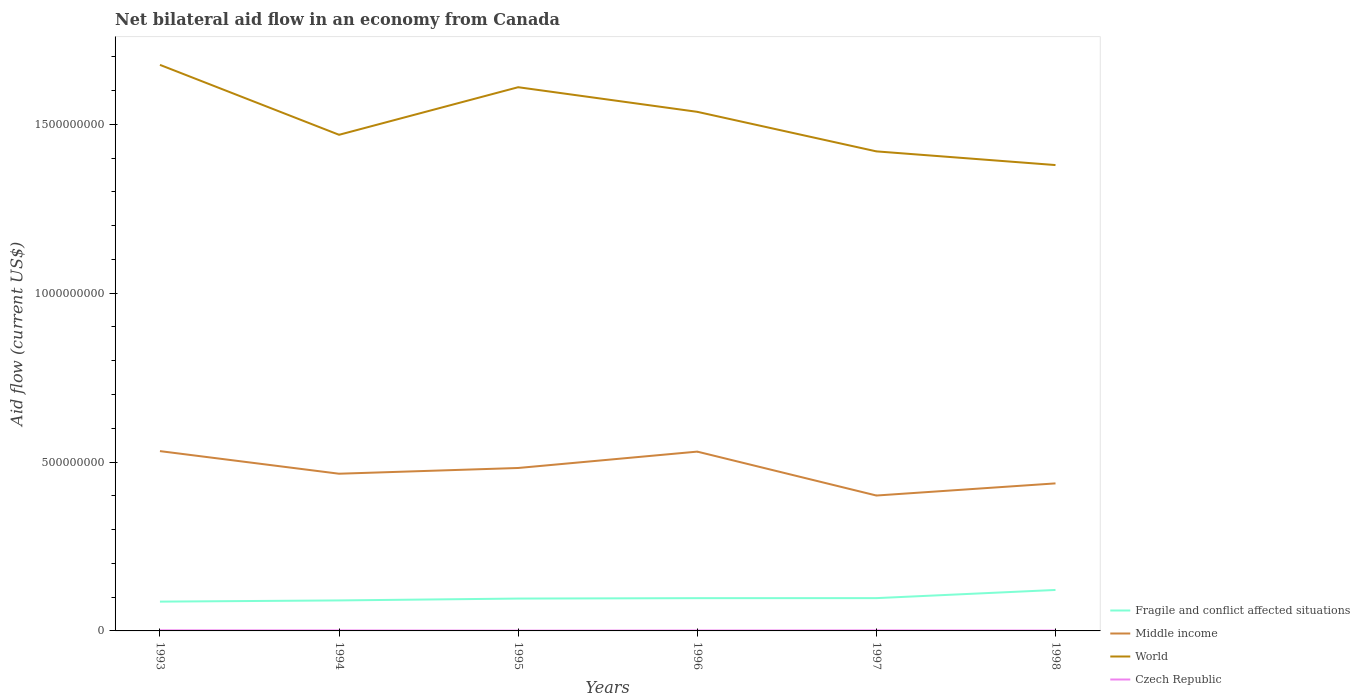How many different coloured lines are there?
Ensure brevity in your answer.  4. In which year was the net bilateral aid flow in Czech Republic maximum?
Your answer should be very brief. 1995. What is the total net bilateral aid flow in World in the graph?
Your response must be concise. 1.58e+08. What is the difference between the highest and the second highest net bilateral aid flow in Middle income?
Provide a short and direct response. 1.31e+08. How many years are there in the graph?
Provide a short and direct response. 6. What is the difference between two consecutive major ticks on the Y-axis?
Your response must be concise. 5.00e+08. Does the graph contain grids?
Your answer should be compact. No. Where does the legend appear in the graph?
Your answer should be compact. Bottom right. How many legend labels are there?
Your response must be concise. 4. What is the title of the graph?
Make the answer very short. Net bilateral aid flow in an economy from Canada. What is the Aid flow (current US$) of Fragile and conflict affected situations in 1993?
Offer a terse response. 8.68e+07. What is the Aid flow (current US$) in Middle income in 1993?
Your answer should be very brief. 5.32e+08. What is the Aid flow (current US$) of World in 1993?
Provide a succinct answer. 1.68e+09. What is the Aid flow (current US$) in Czech Republic in 1993?
Ensure brevity in your answer.  1.81e+06. What is the Aid flow (current US$) in Fragile and conflict affected situations in 1994?
Keep it short and to the point. 9.03e+07. What is the Aid flow (current US$) in Middle income in 1994?
Your response must be concise. 4.66e+08. What is the Aid flow (current US$) in World in 1994?
Your answer should be very brief. 1.47e+09. What is the Aid flow (current US$) of Czech Republic in 1994?
Give a very brief answer. 1.44e+06. What is the Aid flow (current US$) in Fragile and conflict affected situations in 1995?
Ensure brevity in your answer.  9.58e+07. What is the Aid flow (current US$) in Middle income in 1995?
Your answer should be compact. 4.82e+08. What is the Aid flow (current US$) of World in 1995?
Your response must be concise. 1.61e+09. What is the Aid flow (current US$) in Fragile and conflict affected situations in 1996?
Ensure brevity in your answer.  9.70e+07. What is the Aid flow (current US$) in Middle income in 1996?
Provide a short and direct response. 5.31e+08. What is the Aid flow (current US$) in World in 1996?
Offer a very short reply. 1.54e+09. What is the Aid flow (current US$) of Czech Republic in 1996?
Your answer should be compact. 1.26e+06. What is the Aid flow (current US$) in Fragile and conflict affected situations in 1997?
Give a very brief answer. 9.71e+07. What is the Aid flow (current US$) of Middle income in 1997?
Your answer should be very brief. 4.01e+08. What is the Aid flow (current US$) in World in 1997?
Offer a very short reply. 1.42e+09. What is the Aid flow (current US$) of Czech Republic in 1997?
Provide a succinct answer. 1.53e+06. What is the Aid flow (current US$) of Fragile and conflict affected situations in 1998?
Make the answer very short. 1.21e+08. What is the Aid flow (current US$) of Middle income in 1998?
Keep it short and to the point. 4.37e+08. What is the Aid flow (current US$) of World in 1998?
Keep it short and to the point. 1.38e+09. What is the Aid flow (current US$) in Czech Republic in 1998?
Your answer should be very brief. 1.07e+06. Across all years, what is the maximum Aid flow (current US$) in Fragile and conflict affected situations?
Ensure brevity in your answer.  1.21e+08. Across all years, what is the maximum Aid flow (current US$) in Middle income?
Ensure brevity in your answer.  5.32e+08. Across all years, what is the maximum Aid flow (current US$) in World?
Your answer should be compact. 1.68e+09. Across all years, what is the maximum Aid flow (current US$) in Czech Republic?
Provide a short and direct response. 1.81e+06. Across all years, what is the minimum Aid flow (current US$) in Fragile and conflict affected situations?
Provide a short and direct response. 8.68e+07. Across all years, what is the minimum Aid flow (current US$) of Middle income?
Ensure brevity in your answer.  4.01e+08. Across all years, what is the minimum Aid flow (current US$) in World?
Give a very brief answer. 1.38e+09. What is the total Aid flow (current US$) of Fragile and conflict affected situations in the graph?
Make the answer very short. 5.88e+08. What is the total Aid flow (current US$) of Middle income in the graph?
Offer a terse response. 2.85e+09. What is the total Aid flow (current US$) of World in the graph?
Keep it short and to the point. 9.09e+09. What is the total Aid flow (current US$) in Czech Republic in the graph?
Keep it short and to the point. 8.01e+06. What is the difference between the Aid flow (current US$) in Fragile and conflict affected situations in 1993 and that in 1994?
Offer a very short reply. -3.54e+06. What is the difference between the Aid flow (current US$) of Middle income in 1993 and that in 1994?
Offer a very short reply. 6.69e+07. What is the difference between the Aid flow (current US$) of World in 1993 and that in 1994?
Offer a terse response. 2.07e+08. What is the difference between the Aid flow (current US$) in Fragile and conflict affected situations in 1993 and that in 1995?
Keep it short and to the point. -9.03e+06. What is the difference between the Aid flow (current US$) of Middle income in 1993 and that in 1995?
Your answer should be very brief. 4.99e+07. What is the difference between the Aid flow (current US$) in World in 1993 and that in 1995?
Offer a very short reply. 6.62e+07. What is the difference between the Aid flow (current US$) of Czech Republic in 1993 and that in 1995?
Give a very brief answer. 9.10e+05. What is the difference between the Aid flow (current US$) in Fragile and conflict affected situations in 1993 and that in 1996?
Offer a very short reply. -1.03e+07. What is the difference between the Aid flow (current US$) in Middle income in 1993 and that in 1996?
Keep it short and to the point. 1.48e+06. What is the difference between the Aid flow (current US$) of World in 1993 and that in 1996?
Provide a succinct answer. 1.39e+08. What is the difference between the Aid flow (current US$) in Czech Republic in 1993 and that in 1996?
Provide a short and direct response. 5.50e+05. What is the difference between the Aid flow (current US$) of Fragile and conflict affected situations in 1993 and that in 1997?
Provide a succinct answer. -1.03e+07. What is the difference between the Aid flow (current US$) in Middle income in 1993 and that in 1997?
Provide a succinct answer. 1.31e+08. What is the difference between the Aid flow (current US$) of World in 1993 and that in 1997?
Your answer should be very brief. 2.56e+08. What is the difference between the Aid flow (current US$) in Czech Republic in 1993 and that in 1997?
Make the answer very short. 2.80e+05. What is the difference between the Aid flow (current US$) of Fragile and conflict affected situations in 1993 and that in 1998?
Provide a short and direct response. -3.45e+07. What is the difference between the Aid flow (current US$) in Middle income in 1993 and that in 1998?
Make the answer very short. 9.55e+07. What is the difference between the Aid flow (current US$) in World in 1993 and that in 1998?
Keep it short and to the point. 2.97e+08. What is the difference between the Aid flow (current US$) of Czech Republic in 1993 and that in 1998?
Give a very brief answer. 7.40e+05. What is the difference between the Aid flow (current US$) in Fragile and conflict affected situations in 1994 and that in 1995?
Keep it short and to the point. -5.49e+06. What is the difference between the Aid flow (current US$) in Middle income in 1994 and that in 1995?
Make the answer very short. -1.70e+07. What is the difference between the Aid flow (current US$) in World in 1994 and that in 1995?
Keep it short and to the point. -1.41e+08. What is the difference between the Aid flow (current US$) of Czech Republic in 1994 and that in 1995?
Give a very brief answer. 5.40e+05. What is the difference between the Aid flow (current US$) in Fragile and conflict affected situations in 1994 and that in 1996?
Ensure brevity in your answer.  -6.72e+06. What is the difference between the Aid flow (current US$) of Middle income in 1994 and that in 1996?
Provide a short and direct response. -6.54e+07. What is the difference between the Aid flow (current US$) of World in 1994 and that in 1996?
Offer a terse response. -6.80e+07. What is the difference between the Aid flow (current US$) in Czech Republic in 1994 and that in 1996?
Provide a short and direct response. 1.80e+05. What is the difference between the Aid flow (current US$) in Fragile and conflict affected situations in 1994 and that in 1997?
Offer a very short reply. -6.79e+06. What is the difference between the Aid flow (current US$) of Middle income in 1994 and that in 1997?
Offer a terse response. 6.46e+07. What is the difference between the Aid flow (current US$) in World in 1994 and that in 1997?
Offer a very short reply. 4.91e+07. What is the difference between the Aid flow (current US$) in Fragile and conflict affected situations in 1994 and that in 1998?
Your response must be concise. -3.10e+07. What is the difference between the Aid flow (current US$) in Middle income in 1994 and that in 1998?
Offer a very short reply. 2.86e+07. What is the difference between the Aid flow (current US$) in World in 1994 and that in 1998?
Make the answer very short. 8.96e+07. What is the difference between the Aid flow (current US$) in Fragile and conflict affected situations in 1995 and that in 1996?
Your response must be concise. -1.23e+06. What is the difference between the Aid flow (current US$) in Middle income in 1995 and that in 1996?
Keep it short and to the point. -4.85e+07. What is the difference between the Aid flow (current US$) of World in 1995 and that in 1996?
Provide a succinct answer. 7.29e+07. What is the difference between the Aid flow (current US$) in Czech Republic in 1995 and that in 1996?
Ensure brevity in your answer.  -3.60e+05. What is the difference between the Aid flow (current US$) of Fragile and conflict affected situations in 1995 and that in 1997?
Provide a succinct answer. -1.30e+06. What is the difference between the Aid flow (current US$) in Middle income in 1995 and that in 1997?
Your answer should be very brief. 8.15e+07. What is the difference between the Aid flow (current US$) of World in 1995 and that in 1997?
Ensure brevity in your answer.  1.90e+08. What is the difference between the Aid flow (current US$) of Czech Republic in 1995 and that in 1997?
Make the answer very short. -6.30e+05. What is the difference between the Aid flow (current US$) in Fragile and conflict affected situations in 1995 and that in 1998?
Ensure brevity in your answer.  -2.55e+07. What is the difference between the Aid flow (current US$) in Middle income in 1995 and that in 1998?
Give a very brief answer. 4.56e+07. What is the difference between the Aid flow (current US$) of World in 1995 and that in 1998?
Provide a succinct answer. 2.31e+08. What is the difference between the Aid flow (current US$) of Fragile and conflict affected situations in 1996 and that in 1997?
Provide a succinct answer. -7.00e+04. What is the difference between the Aid flow (current US$) of Middle income in 1996 and that in 1997?
Offer a very short reply. 1.30e+08. What is the difference between the Aid flow (current US$) of World in 1996 and that in 1997?
Provide a short and direct response. 1.17e+08. What is the difference between the Aid flow (current US$) of Czech Republic in 1996 and that in 1997?
Your response must be concise. -2.70e+05. What is the difference between the Aid flow (current US$) of Fragile and conflict affected situations in 1996 and that in 1998?
Make the answer very short. -2.43e+07. What is the difference between the Aid flow (current US$) in Middle income in 1996 and that in 1998?
Offer a very short reply. 9.40e+07. What is the difference between the Aid flow (current US$) in World in 1996 and that in 1998?
Ensure brevity in your answer.  1.58e+08. What is the difference between the Aid flow (current US$) in Czech Republic in 1996 and that in 1998?
Give a very brief answer. 1.90e+05. What is the difference between the Aid flow (current US$) of Fragile and conflict affected situations in 1997 and that in 1998?
Offer a very short reply. -2.42e+07. What is the difference between the Aid flow (current US$) in Middle income in 1997 and that in 1998?
Keep it short and to the point. -3.60e+07. What is the difference between the Aid flow (current US$) in World in 1997 and that in 1998?
Provide a short and direct response. 4.05e+07. What is the difference between the Aid flow (current US$) in Czech Republic in 1997 and that in 1998?
Give a very brief answer. 4.60e+05. What is the difference between the Aid flow (current US$) of Fragile and conflict affected situations in 1993 and the Aid flow (current US$) of Middle income in 1994?
Your answer should be very brief. -3.79e+08. What is the difference between the Aid flow (current US$) in Fragile and conflict affected situations in 1993 and the Aid flow (current US$) in World in 1994?
Offer a terse response. -1.38e+09. What is the difference between the Aid flow (current US$) of Fragile and conflict affected situations in 1993 and the Aid flow (current US$) of Czech Republic in 1994?
Keep it short and to the point. 8.53e+07. What is the difference between the Aid flow (current US$) of Middle income in 1993 and the Aid flow (current US$) of World in 1994?
Your answer should be compact. -9.37e+08. What is the difference between the Aid flow (current US$) of Middle income in 1993 and the Aid flow (current US$) of Czech Republic in 1994?
Your response must be concise. 5.31e+08. What is the difference between the Aid flow (current US$) in World in 1993 and the Aid flow (current US$) in Czech Republic in 1994?
Offer a very short reply. 1.67e+09. What is the difference between the Aid flow (current US$) in Fragile and conflict affected situations in 1993 and the Aid flow (current US$) in Middle income in 1995?
Your response must be concise. -3.96e+08. What is the difference between the Aid flow (current US$) in Fragile and conflict affected situations in 1993 and the Aid flow (current US$) in World in 1995?
Keep it short and to the point. -1.52e+09. What is the difference between the Aid flow (current US$) of Fragile and conflict affected situations in 1993 and the Aid flow (current US$) of Czech Republic in 1995?
Offer a terse response. 8.59e+07. What is the difference between the Aid flow (current US$) in Middle income in 1993 and the Aid flow (current US$) in World in 1995?
Provide a succinct answer. -1.08e+09. What is the difference between the Aid flow (current US$) in Middle income in 1993 and the Aid flow (current US$) in Czech Republic in 1995?
Offer a very short reply. 5.32e+08. What is the difference between the Aid flow (current US$) of World in 1993 and the Aid flow (current US$) of Czech Republic in 1995?
Offer a terse response. 1.68e+09. What is the difference between the Aid flow (current US$) of Fragile and conflict affected situations in 1993 and the Aid flow (current US$) of Middle income in 1996?
Provide a short and direct response. -4.44e+08. What is the difference between the Aid flow (current US$) in Fragile and conflict affected situations in 1993 and the Aid flow (current US$) in World in 1996?
Give a very brief answer. -1.45e+09. What is the difference between the Aid flow (current US$) of Fragile and conflict affected situations in 1993 and the Aid flow (current US$) of Czech Republic in 1996?
Make the answer very short. 8.55e+07. What is the difference between the Aid flow (current US$) of Middle income in 1993 and the Aid flow (current US$) of World in 1996?
Offer a very short reply. -1.00e+09. What is the difference between the Aid flow (current US$) in Middle income in 1993 and the Aid flow (current US$) in Czech Republic in 1996?
Your answer should be compact. 5.31e+08. What is the difference between the Aid flow (current US$) in World in 1993 and the Aid flow (current US$) in Czech Republic in 1996?
Provide a succinct answer. 1.67e+09. What is the difference between the Aid flow (current US$) of Fragile and conflict affected situations in 1993 and the Aid flow (current US$) of Middle income in 1997?
Your answer should be very brief. -3.14e+08. What is the difference between the Aid flow (current US$) in Fragile and conflict affected situations in 1993 and the Aid flow (current US$) in World in 1997?
Your answer should be very brief. -1.33e+09. What is the difference between the Aid flow (current US$) of Fragile and conflict affected situations in 1993 and the Aid flow (current US$) of Czech Republic in 1997?
Make the answer very short. 8.52e+07. What is the difference between the Aid flow (current US$) in Middle income in 1993 and the Aid flow (current US$) in World in 1997?
Offer a terse response. -8.88e+08. What is the difference between the Aid flow (current US$) in Middle income in 1993 and the Aid flow (current US$) in Czech Republic in 1997?
Provide a short and direct response. 5.31e+08. What is the difference between the Aid flow (current US$) in World in 1993 and the Aid flow (current US$) in Czech Republic in 1997?
Your response must be concise. 1.67e+09. What is the difference between the Aid flow (current US$) in Fragile and conflict affected situations in 1993 and the Aid flow (current US$) in Middle income in 1998?
Make the answer very short. -3.50e+08. What is the difference between the Aid flow (current US$) of Fragile and conflict affected situations in 1993 and the Aid flow (current US$) of World in 1998?
Provide a succinct answer. -1.29e+09. What is the difference between the Aid flow (current US$) in Fragile and conflict affected situations in 1993 and the Aid flow (current US$) in Czech Republic in 1998?
Keep it short and to the point. 8.57e+07. What is the difference between the Aid flow (current US$) of Middle income in 1993 and the Aid flow (current US$) of World in 1998?
Provide a succinct answer. -8.47e+08. What is the difference between the Aid flow (current US$) in Middle income in 1993 and the Aid flow (current US$) in Czech Republic in 1998?
Provide a succinct answer. 5.31e+08. What is the difference between the Aid flow (current US$) in World in 1993 and the Aid flow (current US$) in Czech Republic in 1998?
Keep it short and to the point. 1.68e+09. What is the difference between the Aid flow (current US$) of Fragile and conflict affected situations in 1994 and the Aid flow (current US$) of Middle income in 1995?
Keep it short and to the point. -3.92e+08. What is the difference between the Aid flow (current US$) in Fragile and conflict affected situations in 1994 and the Aid flow (current US$) in World in 1995?
Offer a terse response. -1.52e+09. What is the difference between the Aid flow (current US$) of Fragile and conflict affected situations in 1994 and the Aid flow (current US$) of Czech Republic in 1995?
Give a very brief answer. 8.94e+07. What is the difference between the Aid flow (current US$) of Middle income in 1994 and the Aid flow (current US$) of World in 1995?
Provide a short and direct response. -1.14e+09. What is the difference between the Aid flow (current US$) of Middle income in 1994 and the Aid flow (current US$) of Czech Republic in 1995?
Give a very brief answer. 4.65e+08. What is the difference between the Aid flow (current US$) of World in 1994 and the Aid flow (current US$) of Czech Republic in 1995?
Offer a terse response. 1.47e+09. What is the difference between the Aid flow (current US$) of Fragile and conflict affected situations in 1994 and the Aid flow (current US$) of Middle income in 1996?
Offer a terse response. -4.41e+08. What is the difference between the Aid flow (current US$) in Fragile and conflict affected situations in 1994 and the Aid flow (current US$) in World in 1996?
Give a very brief answer. -1.45e+09. What is the difference between the Aid flow (current US$) in Fragile and conflict affected situations in 1994 and the Aid flow (current US$) in Czech Republic in 1996?
Your answer should be very brief. 8.90e+07. What is the difference between the Aid flow (current US$) of Middle income in 1994 and the Aid flow (current US$) of World in 1996?
Your answer should be compact. -1.07e+09. What is the difference between the Aid flow (current US$) of Middle income in 1994 and the Aid flow (current US$) of Czech Republic in 1996?
Provide a short and direct response. 4.64e+08. What is the difference between the Aid flow (current US$) of World in 1994 and the Aid flow (current US$) of Czech Republic in 1996?
Your answer should be very brief. 1.47e+09. What is the difference between the Aid flow (current US$) of Fragile and conflict affected situations in 1994 and the Aid flow (current US$) of Middle income in 1997?
Offer a terse response. -3.11e+08. What is the difference between the Aid flow (current US$) in Fragile and conflict affected situations in 1994 and the Aid flow (current US$) in World in 1997?
Offer a very short reply. -1.33e+09. What is the difference between the Aid flow (current US$) of Fragile and conflict affected situations in 1994 and the Aid flow (current US$) of Czech Republic in 1997?
Offer a very short reply. 8.88e+07. What is the difference between the Aid flow (current US$) in Middle income in 1994 and the Aid flow (current US$) in World in 1997?
Your response must be concise. -9.54e+08. What is the difference between the Aid flow (current US$) of Middle income in 1994 and the Aid flow (current US$) of Czech Republic in 1997?
Keep it short and to the point. 4.64e+08. What is the difference between the Aid flow (current US$) in World in 1994 and the Aid flow (current US$) in Czech Republic in 1997?
Give a very brief answer. 1.47e+09. What is the difference between the Aid flow (current US$) in Fragile and conflict affected situations in 1994 and the Aid flow (current US$) in Middle income in 1998?
Provide a short and direct response. -3.47e+08. What is the difference between the Aid flow (current US$) of Fragile and conflict affected situations in 1994 and the Aid flow (current US$) of World in 1998?
Offer a very short reply. -1.29e+09. What is the difference between the Aid flow (current US$) in Fragile and conflict affected situations in 1994 and the Aid flow (current US$) in Czech Republic in 1998?
Your response must be concise. 8.92e+07. What is the difference between the Aid flow (current US$) of Middle income in 1994 and the Aid flow (current US$) of World in 1998?
Offer a terse response. -9.14e+08. What is the difference between the Aid flow (current US$) of Middle income in 1994 and the Aid flow (current US$) of Czech Republic in 1998?
Your response must be concise. 4.64e+08. What is the difference between the Aid flow (current US$) of World in 1994 and the Aid flow (current US$) of Czech Republic in 1998?
Your answer should be very brief. 1.47e+09. What is the difference between the Aid flow (current US$) of Fragile and conflict affected situations in 1995 and the Aid flow (current US$) of Middle income in 1996?
Offer a terse response. -4.35e+08. What is the difference between the Aid flow (current US$) in Fragile and conflict affected situations in 1995 and the Aid flow (current US$) in World in 1996?
Offer a very short reply. -1.44e+09. What is the difference between the Aid flow (current US$) of Fragile and conflict affected situations in 1995 and the Aid flow (current US$) of Czech Republic in 1996?
Give a very brief answer. 9.45e+07. What is the difference between the Aid flow (current US$) in Middle income in 1995 and the Aid flow (current US$) in World in 1996?
Provide a short and direct response. -1.05e+09. What is the difference between the Aid flow (current US$) in Middle income in 1995 and the Aid flow (current US$) in Czech Republic in 1996?
Make the answer very short. 4.81e+08. What is the difference between the Aid flow (current US$) of World in 1995 and the Aid flow (current US$) of Czech Republic in 1996?
Give a very brief answer. 1.61e+09. What is the difference between the Aid flow (current US$) in Fragile and conflict affected situations in 1995 and the Aid flow (current US$) in Middle income in 1997?
Offer a very short reply. -3.05e+08. What is the difference between the Aid flow (current US$) of Fragile and conflict affected situations in 1995 and the Aid flow (current US$) of World in 1997?
Your answer should be compact. -1.32e+09. What is the difference between the Aid flow (current US$) in Fragile and conflict affected situations in 1995 and the Aid flow (current US$) in Czech Republic in 1997?
Provide a succinct answer. 9.43e+07. What is the difference between the Aid flow (current US$) of Middle income in 1995 and the Aid flow (current US$) of World in 1997?
Provide a short and direct response. -9.38e+08. What is the difference between the Aid flow (current US$) of Middle income in 1995 and the Aid flow (current US$) of Czech Republic in 1997?
Offer a very short reply. 4.81e+08. What is the difference between the Aid flow (current US$) in World in 1995 and the Aid flow (current US$) in Czech Republic in 1997?
Keep it short and to the point. 1.61e+09. What is the difference between the Aid flow (current US$) of Fragile and conflict affected situations in 1995 and the Aid flow (current US$) of Middle income in 1998?
Your response must be concise. -3.41e+08. What is the difference between the Aid flow (current US$) in Fragile and conflict affected situations in 1995 and the Aid flow (current US$) in World in 1998?
Ensure brevity in your answer.  -1.28e+09. What is the difference between the Aid flow (current US$) of Fragile and conflict affected situations in 1995 and the Aid flow (current US$) of Czech Republic in 1998?
Offer a very short reply. 9.47e+07. What is the difference between the Aid flow (current US$) of Middle income in 1995 and the Aid flow (current US$) of World in 1998?
Give a very brief answer. -8.97e+08. What is the difference between the Aid flow (current US$) of Middle income in 1995 and the Aid flow (current US$) of Czech Republic in 1998?
Keep it short and to the point. 4.81e+08. What is the difference between the Aid flow (current US$) of World in 1995 and the Aid flow (current US$) of Czech Republic in 1998?
Your answer should be compact. 1.61e+09. What is the difference between the Aid flow (current US$) of Fragile and conflict affected situations in 1996 and the Aid flow (current US$) of Middle income in 1997?
Offer a very short reply. -3.04e+08. What is the difference between the Aid flow (current US$) in Fragile and conflict affected situations in 1996 and the Aid flow (current US$) in World in 1997?
Provide a succinct answer. -1.32e+09. What is the difference between the Aid flow (current US$) of Fragile and conflict affected situations in 1996 and the Aid flow (current US$) of Czech Republic in 1997?
Offer a very short reply. 9.55e+07. What is the difference between the Aid flow (current US$) in Middle income in 1996 and the Aid flow (current US$) in World in 1997?
Your response must be concise. -8.89e+08. What is the difference between the Aid flow (current US$) of Middle income in 1996 and the Aid flow (current US$) of Czech Republic in 1997?
Offer a very short reply. 5.29e+08. What is the difference between the Aid flow (current US$) in World in 1996 and the Aid flow (current US$) in Czech Republic in 1997?
Offer a terse response. 1.54e+09. What is the difference between the Aid flow (current US$) in Fragile and conflict affected situations in 1996 and the Aid flow (current US$) in Middle income in 1998?
Provide a short and direct response. -3.40e+08. What is the difference between the Aid flow (current US$) of Fragile and conflict affected situations in 1996 and the Aid flow (current US$) of World in 1998?
Provide a short and direct response. -1.28e+09. What is the difference between the Aid flow (current US$) in Fragile and conflict affected situations in 1996 and the Aid flow (current US$) in Czech Republic in 1998?
Offer a terse response. 9.60e+07. What is the difference between the Aid flow (current US$) in Middle income in 1996 and the Aid flow (current US$) in World in 1998?
Make the answer very short. -8.49e+08. What is the difference between the Aid flow (current US$) in Middle income in 1996 and the Aid flow (current US$) in Czech Republic in 1998?
Provide a short and direct response. 5.30e+08. What is the difference between the Aid flow (current US$) in World in 1996 and the Aid flow (current US$) in Czech Republic in 1998?
Offer a very short reply. 1.54e+09. What is the difference between the Aid flow (current US$) in Fragile and conflict affected situations in 1997 and the Aid flow (current US$) in Middle income in 1998?
Make the answer very short. -3.40e+08. What is the difference between the Aid flow (current US$) in Fragile and conflict affected situations in 1997 and the Aid flow (current US$) in World in 1998?
Keep it short and to the point. -1.28e+09. What is the difference between the Aid flow (current US$) of Fragile and conflict affected situations in 1997 and the Aid flow (current US$) of Czech Republic in 1998?
Offer a very short reply. 9.60e+07. What is the difference between the Aid flow (current US$) of Middle income in 1997 and the Aid flow (current US$) of World in 1998?
Your answer should be compact. -9.79e+08. What is the difference between the Aid flow (current US$) in Middle income in 1997 and the Aid flow (current US$) in Czech Republic in 1998?
Make the answer very short. 4.00e+08. What is the difference between the Aid flow (current US$) in World in 1997 and the Aid flow (current US$) in Czech Republic in 1998?
Offer a very short reply. 1.42e+09. What is the average Aid flow (current US$) of Fragile and conflict affected situations per year?
Your response must be concise. 9.81e+07. What is the average Aid flow (current US$) of Middle income per year?
Your answer should be compact. 4.75e+08. What is the average Aid flow (current US$) of World per year?
Make the answer very short. 1.52e+09. What is the average Aid flow (current US$) in Czech Republic per year?
Your response must be concise. 1.34e+06. In the year 1993, what is the difference between the Aid flow (current US$) of Fragile and conflict affected situations and Aid flow (current US$) of Middle income?
Your response must be concise. -4.46e+08. In the year 1993, what is the difference between the Aid flow (current US$) of Fragile and conflict affected situations and Aid flow (current US$) of World?
Give a very brief answer. -1.59e+09. In the year 1993, what is the difference between the Aid flow (current US$) in Fragile and conflict affected situations and Aid flow (current US$) in Czech Republic?
Give a very brief answer. 8.50e+07. In the year 1993, what is the difference between the Aid flow (current US$) in Middle income and Aid flow (current US$) in World?
Provide a short and direct response. -1.14e+09. In the year 1993, what is the difference between the Aid flow (current US$) of Middle income and Aid flow (current US$) of Czech Republic?
Ensure brevity in your answer.  5.31e+08. In the year 1993, what is the difference between the Aid flow (current US$) in World and Aid flow (current US$) in Czech Republic?
Give a very brief answer. 1.67e+09. In the year 1994, what is the difference between the Aid flow (current US$) of Fragile and conflict affected situations and Aid flow (current US$) of Middle income?
Give a very brief answer. -3.75e+08. In the year 1994, what is the difference between the Aid flow (current US$) in Fragile and conflict affected situations and Aid flow (current US$) in World?
Provide a succinct answer. -1.38e+09. In the year 1994, what is the difference between the Aid flow (current US$) of Fragile and conflict affected situations and Aid flow (current US$) of Czech Republic?
Your answer should be very brief. 8.89e+07. In the year 1994, what is the difference between the Aid flow (current US$) in Middle income and Aid flow (current US$) in World?
Offer a terse response. -1.00e+09. In the year 1994, what is the difference between the Aid flow (current US$) in Middle income and Aid flow (current US$) in Czech Republic?
Your response must be concise. 4.64e+08. In the year 1994, what is the difference between the Aid flow (current US$) of World and Aid flow (current US$) of Czech Republic?
Provide a short and direct response. 1.47e+09. In the year 1995, what is the difference between the Aid flow (current US$) in Fragile and conflict affected situations and Aid flow (current US$) in Middle income?
Your answer should be compact. -3.87e+08. In the year 1995, what is the difference between the Aid flow (current US$) in Fragile and conflict affected situations and Aid flow (current US$) in World?
Make the answer very short. -1.51e+09. In the year 1995, what is the difference between the Aid flow (current US$) in Fragile and conflict affected situations and Aid flow (current US$) in Czech Republic?
Your response must be concise. 9.49e+07. In the year 1995, what is the difference between the Aid flow (current US$) in Middle income and Aid flow (current US$) in World?
Your answer should be compact. -1.13e+09. In the year 1995, what is the difference between the Aid flow (current US$) in Middle income and Aid flow (current US$) in Czech Republic?
Provide a short and direct response. 4.82e+08. In the year 1995, what is the difference between the Aid flow (current US$) of World and Aid flow (current US$) of Czech Republic?
Offer a very short reply. 1.61e+09. In the year 1996, what is the difference between the Aid flow (current US$) in Fragile and conflict affected situations and Aid flow (current US$) in Middle income?
Keep it short and to the point. -4.34e+08. In the year 1996, what is the difference between the Aid flow (current US$) in Fragile and conflict affected situations and Aid flow (current US$) in World?
Make the answer very short. -1.44e+09. In the year 1996, what is the difference between the Aid flow (current US$) of Fragile and conflict affected situations and Aid flow (current US$) of Czech Republic?
Offer a very short reply. 9.58e+07. In the year 1996, what is the difference between the Aid flow (current US$) in Middle income and Aid flow (current US$) in World?
Your answer should be very brief. -1.01e+09. In the year 1996, what is the difference between the Aid flow (current US$) of Middle income and Aid flow (current US$) of Czech Republic?
Your answer should be compact. 5.30e+08. In the year 1996, what is the difference between the Aid flow (current US$) of World and Aid flow (current US$) of Czech Republic?
Offer a very short reply. 1.54e+09. In the year 1997, what is the difference between the Aid flow (current US$) in Fragile and conflict affected situations and Aid flow (current US$) in Middle income?
Keep it short and to the point. -3.04e+08. In the year 1997, what is the difference between the Aid flow (current US$) of Fragile and conflict affected situations and Aid flow (current US$) of World?
Offer a very short reply. -1.32e+09. In the year 1997, what is the difference between the Aid flow (current US$) of Fragile and conflict affected situations and Aid flow (current US$) of Czech Republic?
Your answer should be very brief. 9.56e+07. In the year 1997, what is the difference between the Aid flow (current US$) in Middle income and Aid flow (current US$) in World?
Offer a very short reply. -1.02e+09. In the year 1997, what is the difference between the Aid flow (current US$) of Middle income and Aid flow (current US$) of Czech Republic?
Provide a succinct answer. 3.99e+08. In the year 1997, what is the difference between the Aid flow (current US$) in World and Aid flow (current US$) in Czech Republic?
Keep it short and to the point. 1.42e+09. In the year 1998, what is the difference between the Aid flow (current US$) of Fragile and conflict affected situations and Aid flow (current US$) of Middle income?
Keep it short and to the point. -3.16e+08. In the year 1998, what is the difference between the Aid flow (current US$) of Fragile and conflict affected situations and Aid flow (current US$) of World?
Keep it short and to the point. -1.26e+09. In the year 1998, what is the difference between the Aid flow (current US$) in Fragile and conflict affected situations and Aid flow (current US$) in Czech Republic?
Keep it short and to the point. 1.20e+08. In the year 1998, what is the difference between the Aid flow (current US$) of Middle income and Aid flow (current US$) of World?
Keep it short and to the point. -9.43e+08. In the year 1998, what is the difference between the Aid flow (current US$) in Middle income and Aid flow (current US$) in Czech Republic?
Ensure brevity in your answer.  4.36e+08. In the year 1998, what is the difference between the Aid flow (current US$) of World and Aid flow (current US$) of Czech Republic?
Keep it short and to the point. 1.38e+09. What is the ratio of the Aid flow (current US$) of Fragile and conflict affected situations in 1993 to that in 1994?
Give a very brief answer. 0.96. What is the ratio of the Aid flow (current US$) of Middle income in 1993 to that in 1994?
Offer a very short reply. 1.14. What is the ratio of the Aid flow (current US$) of World in 1993 to that in 1994?
Ensure brevity in your answer.  1.14. What is the ratio of the Aid flow (current US$) of Czech Republic in 1993 to that in 1994?
Provide a succinct answer. 1.26. What is the ratio of the Aid flow (current US$) of Fragile and conflict affected situations in 1993 to that in 1995?
Give a very brief answer. 0.91. What is the ratio of the Aid flow (current US$) in Middle income in 1993 to that in 1995?
Offer a very short reply. 1.1. What is the ratio of the Aid flow (current US$) in World in 1993 to that in 1995?
Ensure brevity in your answer.  1.04. What is the ratio of the Aid flow (current US$) in Czech Republic in 1993 to that in 1995?
Make the answer very short. 2.01. What is the ratio of the Aid flow (current US$) of Fragile and conflict affected situations in 1993 to that in 1996?
Keep it short and to the point. 0.89. What is the ratio of the Aid flow (current US$) of World in 1993 to that in 1996?
Your answer should be compact. 1.09. What is the ratio of the Aid flow (current US$) of Czech Republic in 1993 to that in 1996?
Offer a terse response. 1.44. What is the ratio of the Aid flow (current US$) of Fragile and conflict affected situations in 1993 to that in 1997?
Make the answer very short. 0.89. What is the ratio of the Aid flow (current US$) in Middle income in 1993 to that in 1997?
Offer a very short reply. 1.33. What is the ratio of the Aid flow (current US$) in World in 1993 to that in 1997?
Provide a succinct answer. 1.18. What is the ratio of the Aid flow (current US$) of Czech Republic in 1993 to that in 1997?
Give a very brief answer. 1.18. What is the ratio of the Aid flow (current US$) in Fragile and conflict affected situations in 1993 to that in 1998?
Your answer should be very brief. 0.72. What is the ratio of the Aid flow (current US$) in Middle income in 1993 to that in 1998?
Offer a terse response. 1.22. What is the ratio of the Aid flow (current US$) of World in 1993 to that in 1998?
Your response must be concise. 1.22. What is the ratio of the Aid flow (current US$) in Czech Republic in 1993 to that in 1998?
Provide a short and direct response. 1.69. What is the ratio of the Aid flow (current US$) of Fragile and conflict affected situations in 1994 to that in 1995?
Make the answer very short. 0.94. What is the ratio of the Aid flow (current US$) of Middle income in 1994 to that in 1995?
Offer a terse response. 0.96. What is the ratio of the Aid flow (current US$) in World in 1994 to that in 1995?
Ensure brevity in your answer.  0.91. What is the ratio of the Aid flow (current US$) in Czech Republic in 1994 to that in 1995?
Your answer should be compact. 1.6. What is the ratio of the Aid flow (current US$) in Fragile and conflict affected situations in 1994 to that in 1996?
Your response must be concise. 0.93. What is the ratio of the Aid flow (current US$) of Middle income in 1994 to that in 1996?
Make the answer very short. 0.88. What is the ratio of the Aid flow (current US$) in World in 1994 to that in 1996?
Offer a terse response. 0.96. What is the ratio of the Aid flow (current US$) in Fragile and conflict affected situations in 1994 to that in 1997?
Your answer should be very brief. 0.93. What is the ratio of the Aid flow (current US$) in Middle income in 1994 to that in 1997?
Your response must be concise. 1.16. What is the ratio of the Aid flow (current US$) in World in 1994 to that in 1997?
Provide a short and direct response. 1.03. What is the ratio of the Aid flow (current US$) in Czech Republic in 1994 to that in 1997?
Your answer should be compact. 0.94. What is the ratio of the Aid flow (current US$) in Fragile and conflict affected situations in 1994 to that in 1998?
Provide a short and direct response. 0.74. What is the ratio of the Aid flow (current US$) in Middle income in 1994 to that in 1998?
Provide a short and direct response. 1.07. What is the ratio of the Aid flow (current US$) of World in 1994 to that in 1998?
Your response must be concise. 1.06. What is the ratio of the Aid flow (current US$) of Czech Republic in 1994 to that in 1998?
Offer a terse response. 1.35. What is the ratio of the Aid flow (current US$) of Fragile and conflict affected situations in 1995 to that in 1996?
Provide a succinct answer. 0.99. What is the ratio of the Aid flow (current US$) in Middle income in 1995 to that in 1996?
Your answer should be very brief. 0.91. What is the ratio of the Aid flow (current US$) of World in 1995 to that in 1996?
Provide a short and direct response. 1.05. What is the ratio of the Aid flow (current US$) in Fragile and conflict affected situations in 1995 to that in 1997?
Keep it short and to the point. 0.99. What is the ratio of the Aid flow (current US$) in Middle income in 1995 to that in 1997?
Your answer should be very brief. 1.2. What is the ratio of the Aid flow (current US$) of World in 1995 to that in 1997?
Make the answer very short. 1.13. What is the ratio of the Aid flow (current US$) of Czech Republic in 1995 to that in 1997?
Your answer should be compact. 0.59. What is the ratio of the Aid flow (current US$) in Fragile and conflict affected situations in 1995 to that in 1998?
Your answer should be compact. 0.79. What is the ratio of the Aid flow (current US$) in Middle income in 1995 to that in 1998?
Your response must be concise. 1.1. What is the ratio of the Aid flow (current US$) in World in 1995 to that in 1998?
Ensure brevity in your answer.  1.17. What is the ratio of the Aid flow (current US$) of Czech Republic in 1995 to that in 1998?
Offer a terse response. 0.84. What is the ratio of the Aid flow (current US$) of Middle income in 1996 to that in 1997?
Offer a terse response. 1.32. What is the ratio of the Aid flow (current US$) in World in 1996 to that in 1997?
Provide a succinct answer. 1.08. What is the ratio of the Aid flow (current US$) of Czech Republic in 1996 to that in 1997?
Ensure brevity in your answer.  0.82. What is the ratio of the Aid flow (current US$) in Fragile and conflict affected situations in 1996 to that in 1998?
Give a very brief answer. 0.8. What is the ratio of the Aid flow (current US$) in Middle income in 1996 to that in 1998?
Provide a succinct answer. 1.22. What is the ratio of the Aid flow (current US$) in World in 1996 to that in 1998?
Offer a terse response. 1.11. What is the ratio of the Aid flow (current US$) in Czech Republic in 1996 to that in 1998?
Make the answer very short. 1.18. What is the ratio of the Aid flow (current US$) in Fragile and conflict affected situations in 1997 to that in 1998?
Provide a short and direct response. 0.8. What is the ratio of the Aid flow (current US$) in Middle income in 1997 to that in 1998?
Your response must be concise. 0.92. What is the ratio of the Aid flow (current US$) of World in 1997 to that in 1998?
Your answer should be very brief. 1.03. What is the ratio of the Aid flow (current US$) in Czech Republic in 1997 to that in 1998?
Keep it short and to the point. 1.43. What is the difference between the highest and the second highest Aid flow (current US$) in Fragile and conflict affected situations?
Make the answer very short. 2.42e+07. What is the difference between the highest and the second highest Aid flow (current US$) in Middle income?
Offer a very short reply. 1.48e+06. What is the difference between the highest and the second highest Aid flow (current US$) in World?
Your answer should be compact. 6.62e+07. What is the difference between the highest and the lowest Aid flow (current US$) in Fragile and conflict affected situations?
Your answer should be very brief. 3.45e+07. What is the difference between the highest and the lowest Aid flow (current US$) of Middle income?
Your response must be concise. 1.31e+08. What is the difference between the highest and the lowest Aid flow (current US$) of World?
Offer a very short reply. 2.97e+08. What is the difference between the highest and the lowest Aid flow (current US$) of Czech Republic?
Make the answer very short. 9.10e+05. 